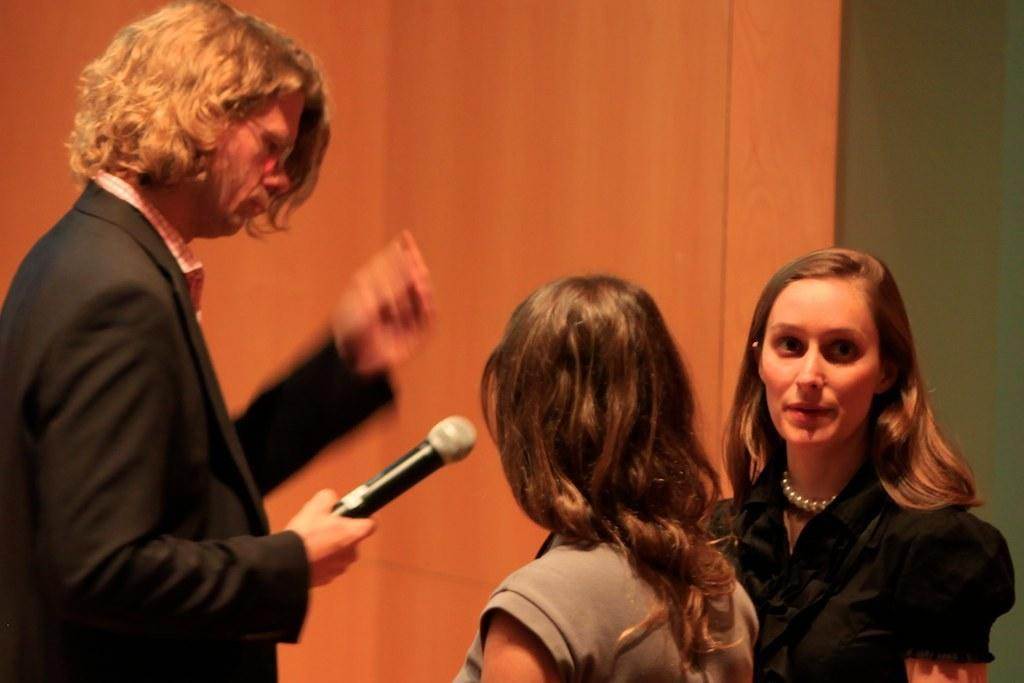What is the person in the image wearing? The person is wearing a black coat in the image. What is the person holding in the image? The person is holding a mic in the image. How many ladies are standing near the person? There are two ladies standing near the person in the image. What can be seen in the background of the image? There is a wall in the background of the image. What is the person's uncle doing in the image? There is no mention of an uncle in the image, so we cannot answer this question. 